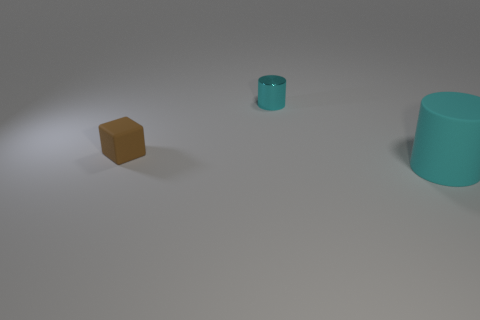Add 1 tiny matte blocks. How many objects exist? 4 Subtract all cubes. How many objects are left? 2 Subtract all small rubber cubes. Subtract all blocks. How many objects are left? 1 Add 2 small brown rubber cubes. How many small brown rubber cubes are left? 3 Add 2 brown matte cubes. How many brown matte cubes exist? 3 Subtract 1 brown blocks. How many objects are left? 2 